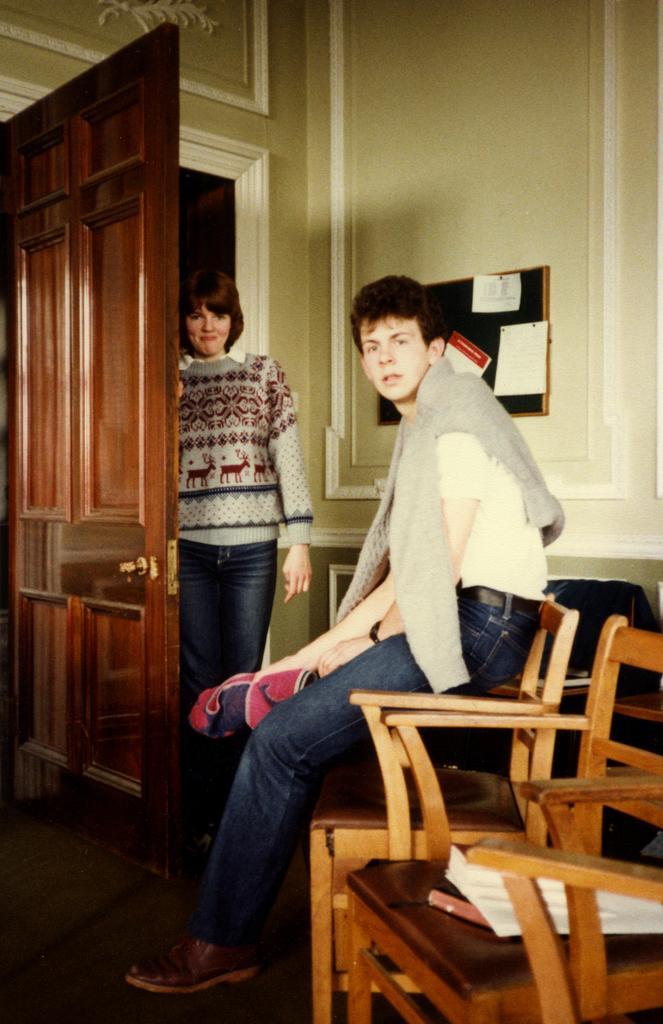In one or two sentences, can you explain what this image depicts? In this picture there are two persons, one woman and a man. He is wearing a white t shirt, blue jeans , brown shoes and a grey shrug. Beside him there is a woman holding a door, she is wearing a grey sweater and blue jeans. In the background there is a wall and a board attached to it. To the bottom right there is a chair, on the chair there are some papers. 